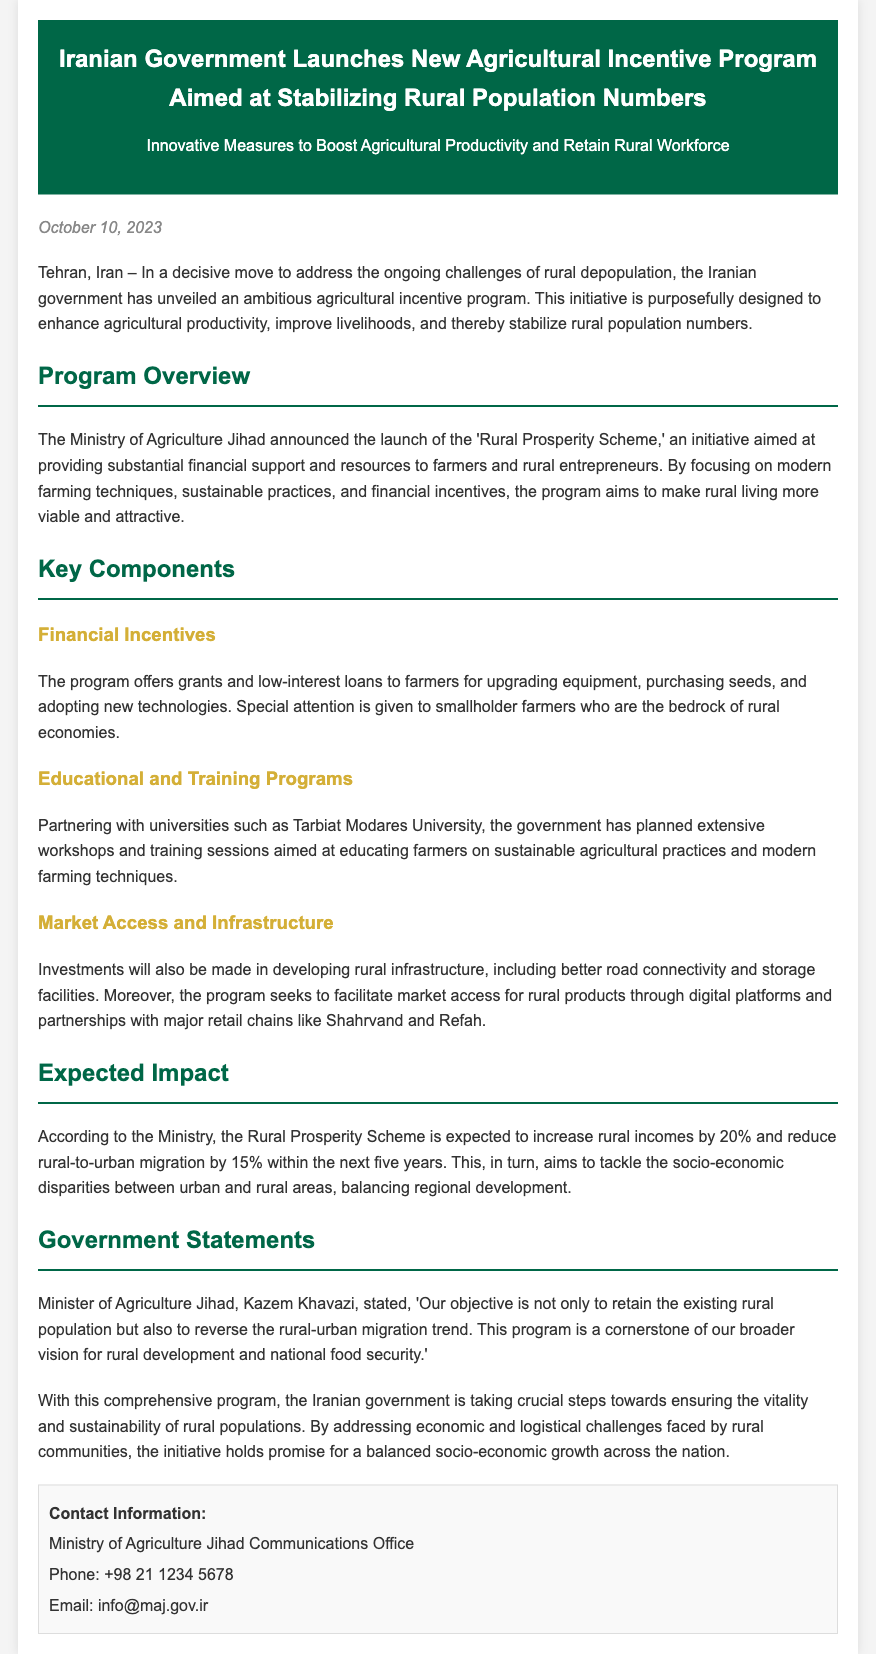what is the title of the program launched by the Iranian government? The title of the program is mentioned in the header section of the document.
Answer: Rural Prosperity Scheme when was the press release published? The publication date is stated at the top of the document below the header.
Answer: October 10, 2023 who is the Minister of Agriculture Jihad? The Minister’s name is provided in the Government Statements section.
Answer: Kazem Khavazi what percentage increase in rural incomes does the program expect? The expected increase in rural incomes is specified under the Expected Impact section.
Answer: 20% which universities are partnering for educational programs? The university participating in the initiative is mentioned in the Key Components section.
Answer: Tarbiat Modares University how much does the program aim to reduce rural-to-urban migration? The expected reduction in rural-to-urban migration is outlined in the Expected Impact section.
Answer: 15% what is the main objective of the new agricultural program? The main objective is clarified by the Minister's statement in the Government Statements section.
Answer: Retain the existing rural population what type of support does the program offer to smallholder farmers? The types of support are described under Key Components, specifically in the Financial Incentives.
Answer: Grants and low-interest loans what infrastructure improvements are expected from the program? Investments in rural infrastructure improvements are detailed in the Market Access and Infrastructure section.
Answer: Better road connectivity and storage facilities 